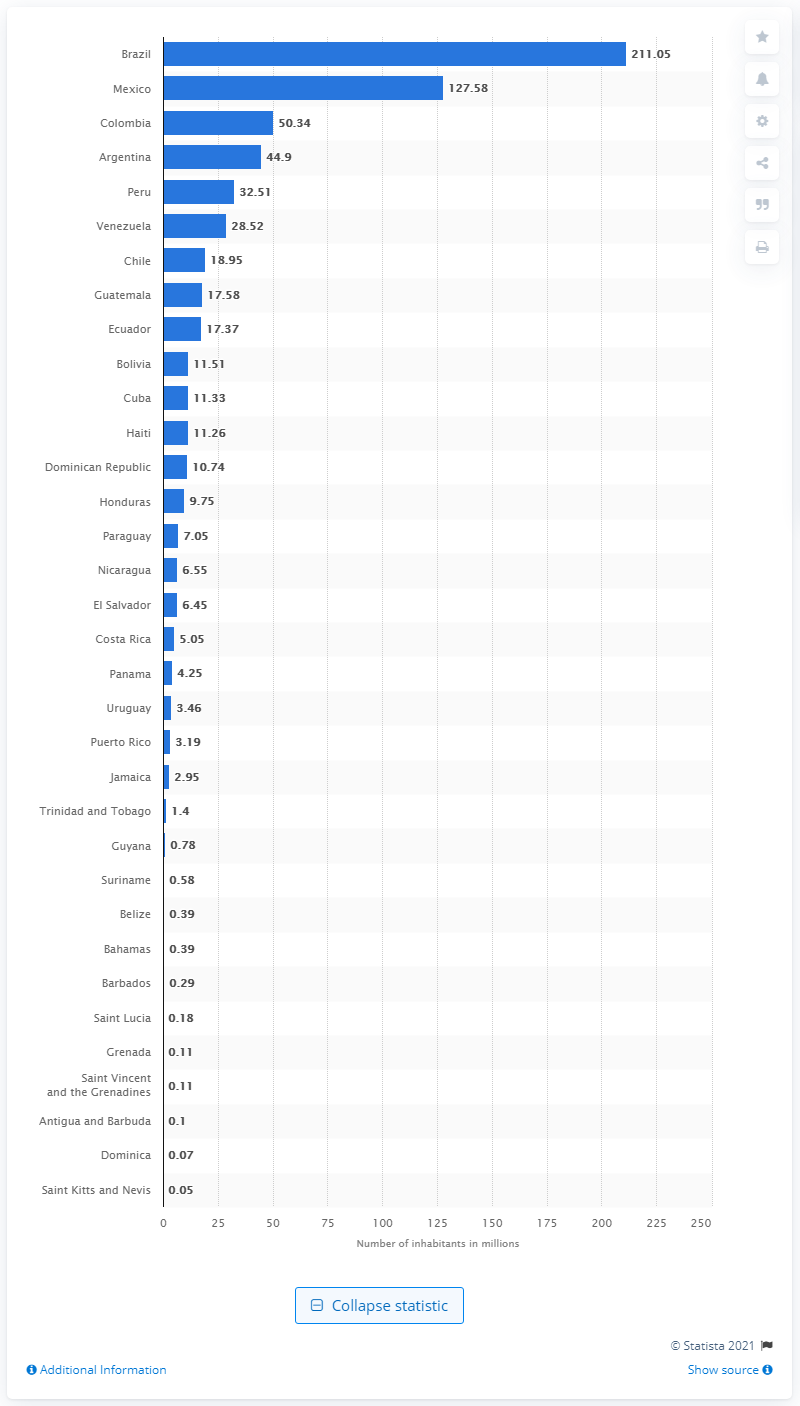Specify some key components in this picture. According to data from 2019, Brazil was the country with the highest population in the region. 